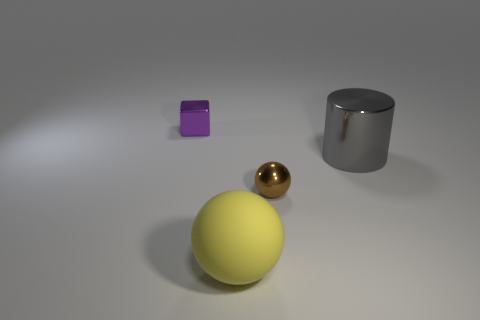Is there any other thing that is the same shape as the purple object?
Provide a succinct answer. No. Do the matte sphere and the thing that is right of the tiny brown metal thing have the same size?
Offer a terse response. Yes. There is a shiny object left of the large thing in front of the large thing behind the large yellow thing; what shape is it?
Ensure brevity in your answer.  Cube. Is the number of small green rubber spheres less than the number of shiny blocks?
Offer a terse response. Yes. Are there any big gray metallic objects right of the big gray metal cylinder?
Your answer should be very brief. No. What is the shape of the metal object that is both behind the small ball and right of the tiny block?
Ensure brevity in your answer.  Cylinder. Is there a tiny metallic thing of the same shape as the matte object?
Your response must be concise. Yes. Does the metallic thing that is behind the gray cylinder have the same size as the shiny object in front of the gray shiny thing?
Provide a succinct answer. Yes. Is the number of tiny shiny balls greater than the number of red shiny spheres?
Ensure brevity in your answer.  Yes. How many big cylinders have the same material as the small purple object?
Give a very brief answer. 1. 